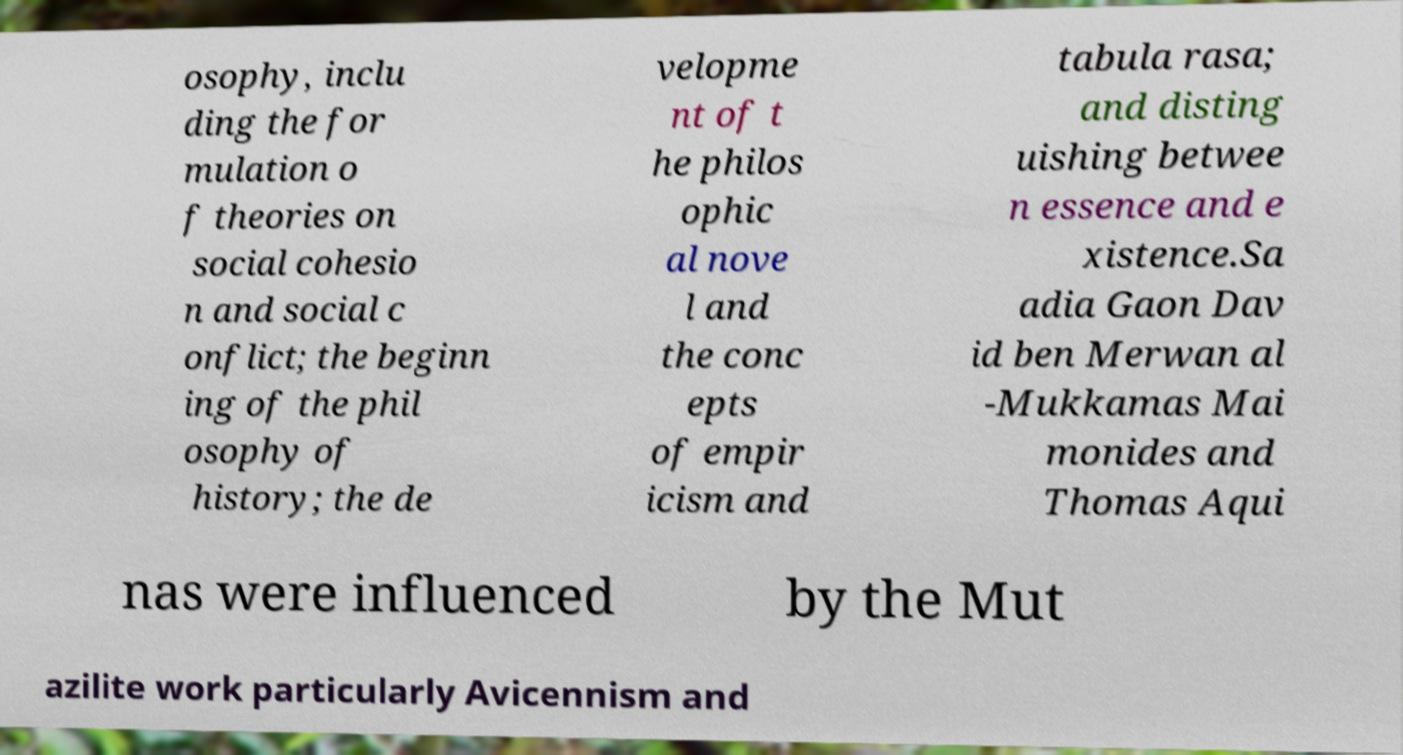Please identify and transcribe the text found in this image. osophy, inclu ding the for mulation o f theories on social cohesio n and social c onflict; the beginn ing of the phil osophy of history; the de velopme nt of t he philos ophic al nove l and the conc epts of empir icism and tabula rasa; and disting uishing betwee n essence and e xistence.Sa adia Gaon Dav id ben Merwan al -Mukkamas Mai monides and Thomas Aqui nas were influenced by the Mut azilite work particularly Avicennism and 